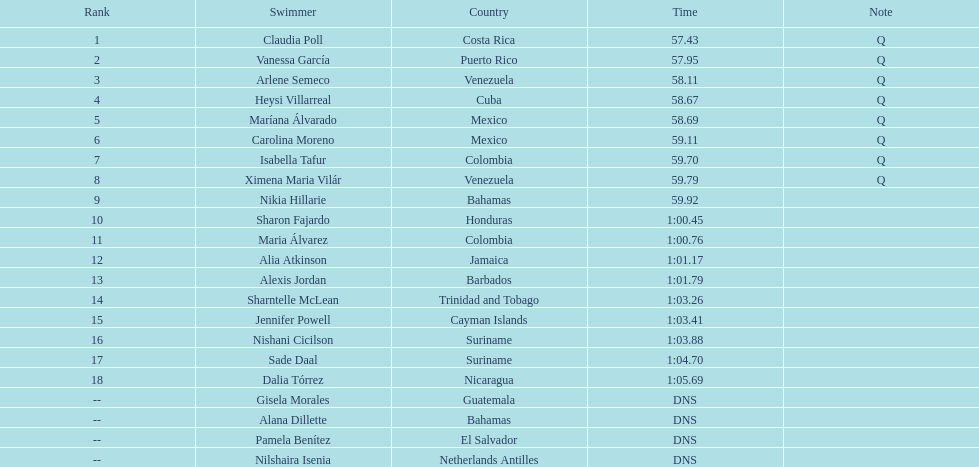Who was the only cuban to finish in the top eight? Heysi Villarreal. 